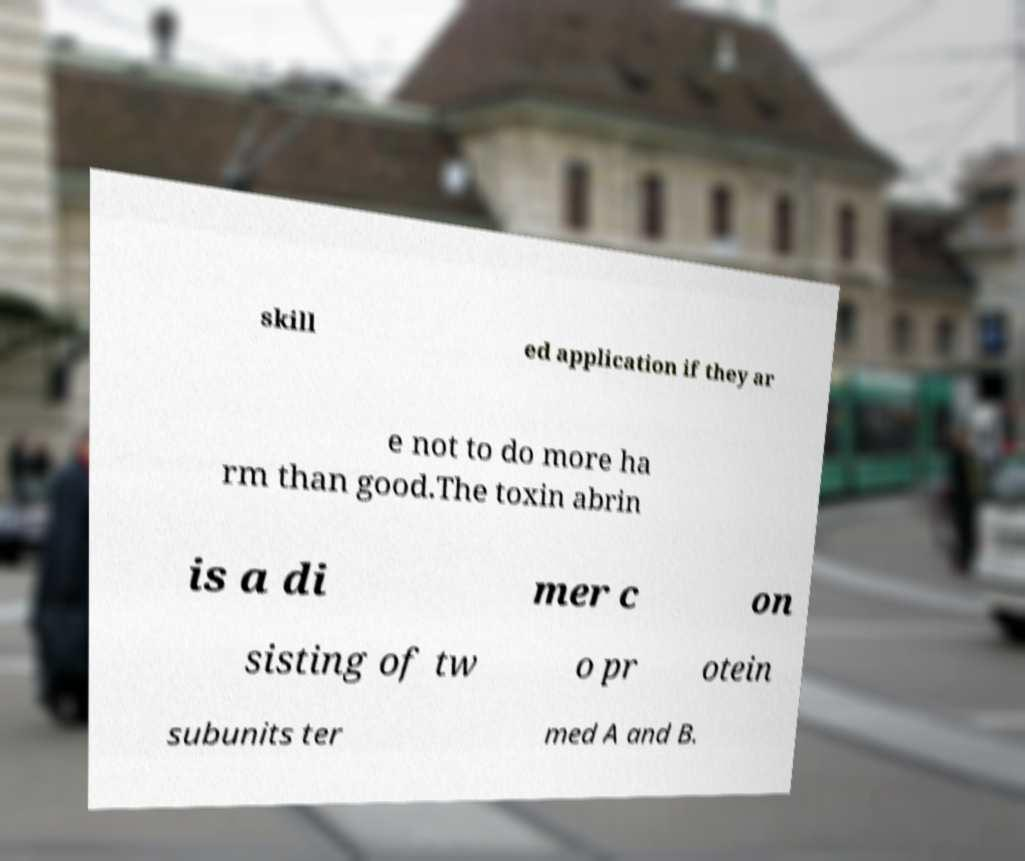Can you read and provide the text displayed in the image?This photo seems to have some interesting text. Can you extract and type it out for me? skill ed application if they ar e not to do more ha rm than good.The toxin abrin is a di mer c on sisting of tw o pr otein subunits ter med A and B. 